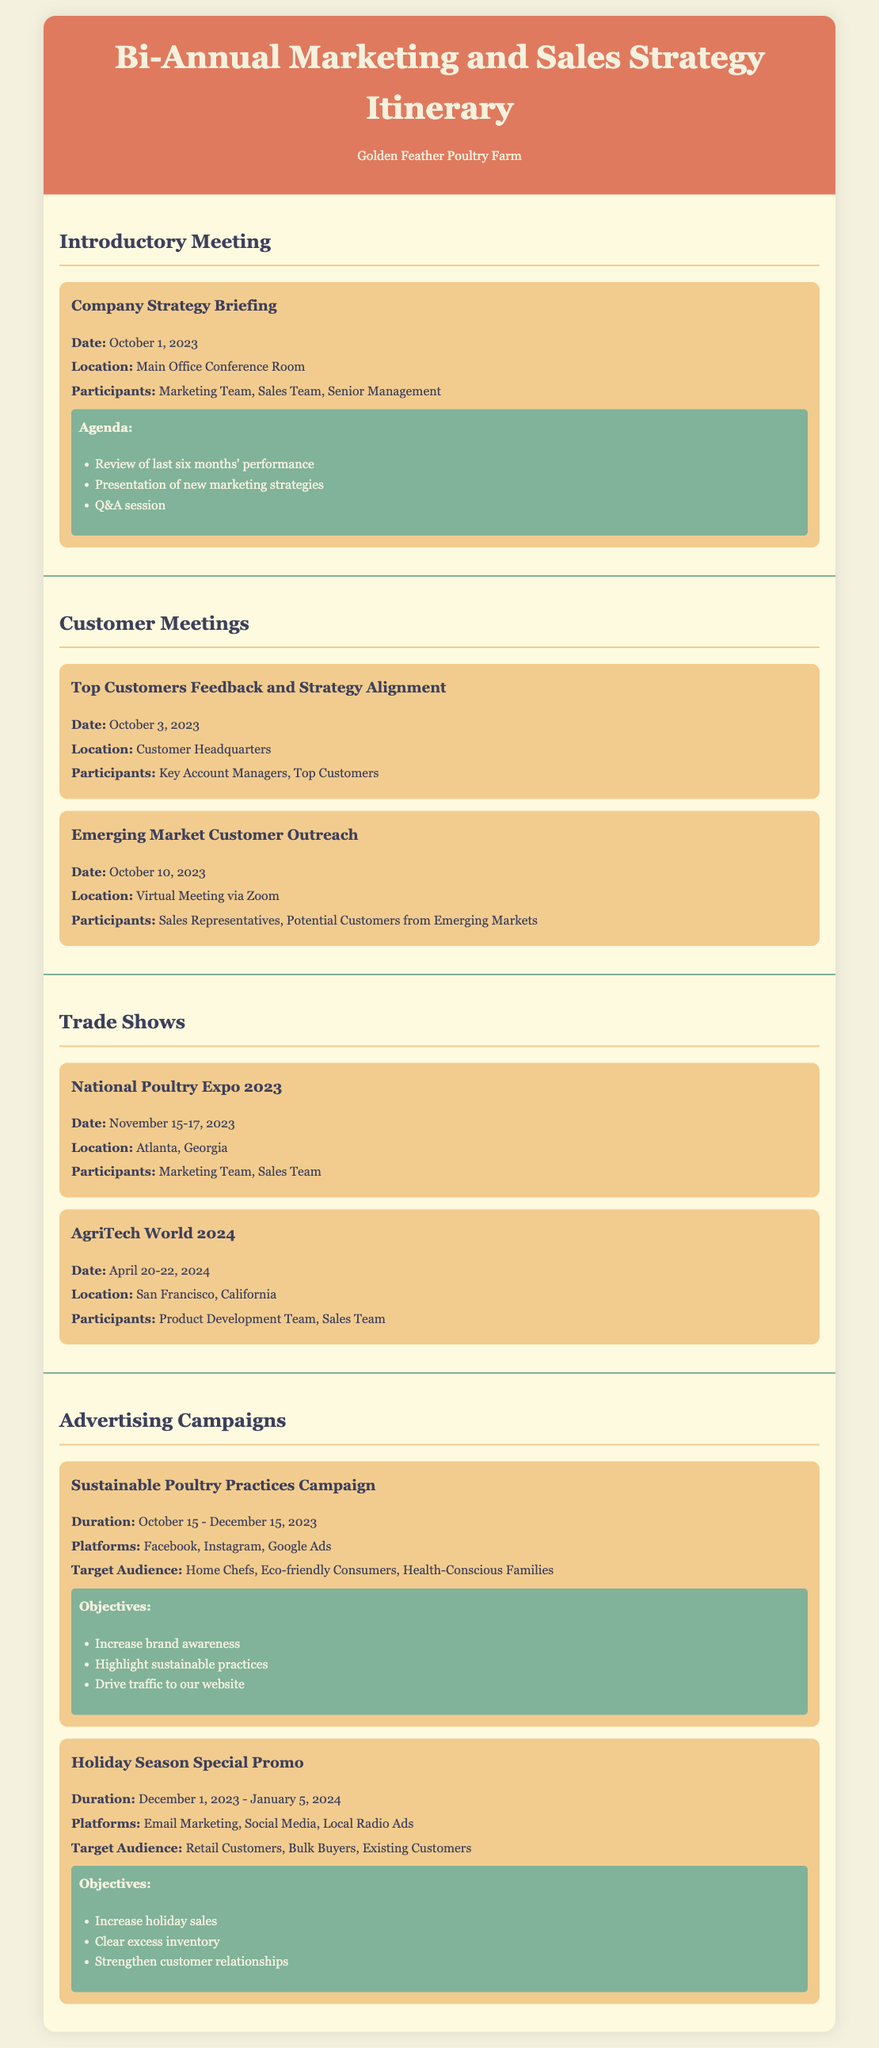What is the date of the Company Strategy Briefing? The date is specified in the itinerary under the introductory meeting section.
Answer: October 1, 2023 Where will the National Poultry Expo take place? The location is mentioned in the trade shows section of the document.
Answer: Atlanta, Georgia Who are the participants for the Holiday Season Special Promo campaign? The target audience is detailed in the advertising campaigns section.
Answer: Retail Customers, Bulk Buyers, Existing Customers What is the duration of the Sustainable Poultry Practices Campaign? The duration is outlined in the advertising campaigns section of the itinerary.
Answer: October 15 - December 15, 2023 How many days will the National Poultry Expo last? The number of days is calculated from the date range provided in the trade shows section.
Answer: 3 days What is the main objective of the Holiday Season Special Promo? The objectives are listed in the advertising campaigns section.
Answer: Increase holiday sales When is the Emerging Market Customer Outreach scheduled? The date is specified in the customer meetings section.
Answer: October 10, 2023 Who are the participants in the Top Customers Feedback and Strategy Alignment meeting? The participants are mentioned in the customer meetings section.
Answer: Key Account Managers, Top Customers What is the location of the Company Strategy Briefing? The location is provided in the introductory meeting section of the itinerary.
Answer: Main Office Conference Room 